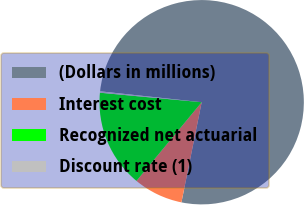<chart> <loc_0><loc_0><loc_500><loc_500><pie_chart><fcel>(Dollars in millions)<fcel>Interest cost<fcel>Recognized net actuarial<fcel>Discount rate (1)<nl><fcel>76.47%<fcel>7.84%<fcel>15.47%<fcel>0.22%<nl></chart> 